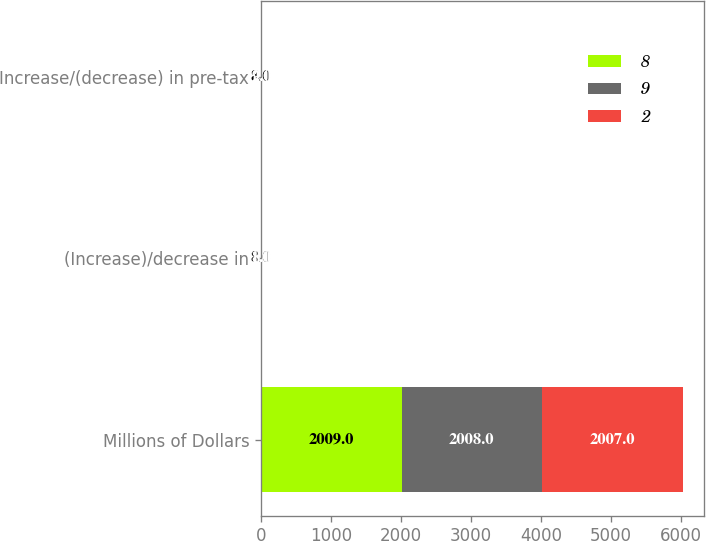Convert chart. <chart><loc_0><loc_0><loc_500><loc_500><stacked_bar_chart><ecel><fcel>Millions of Dollars<fcel>(Increase)/decrease in<fcel>Increase/(decrease) in pre-tax<nl><fcel>8<fcel>2009<fcel>8<fcel>8<nl><fcel>9<fcel>2008<fcel>1<fcel>2<nl><fcel>2<fcel>2007<fcel>8<fcel>9<nl></chart> 